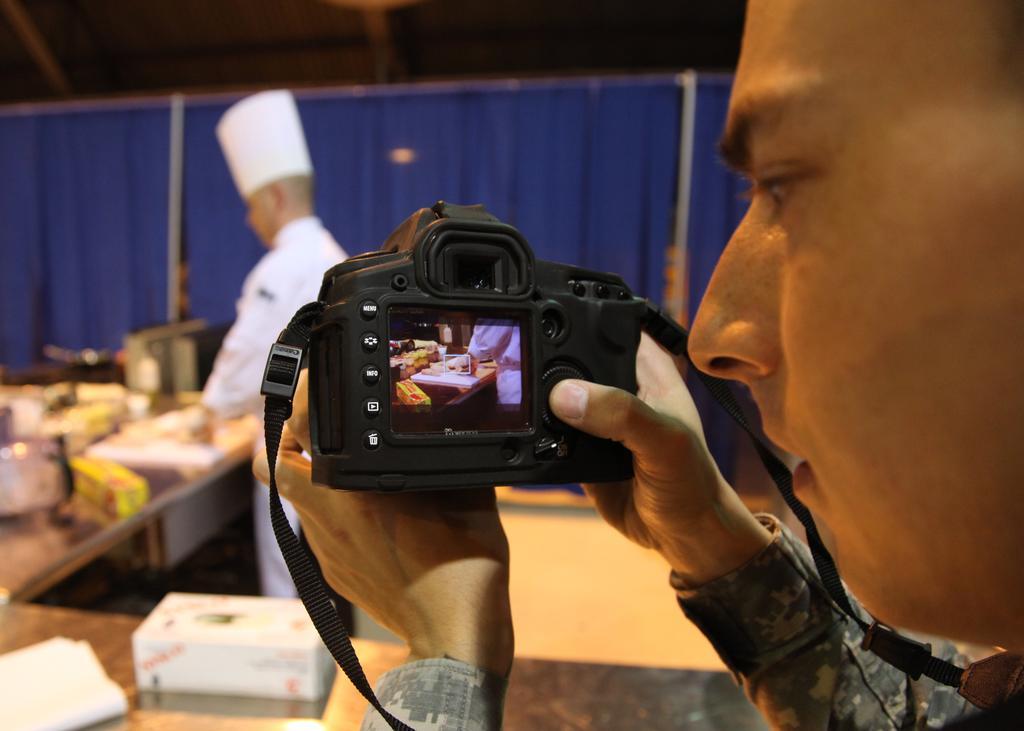Describe this image in one or two sentences. In this picture we can see a man holding camera and focusing the person behind the lens who is a chef and in front of him there is a table and the camera is black in color. 